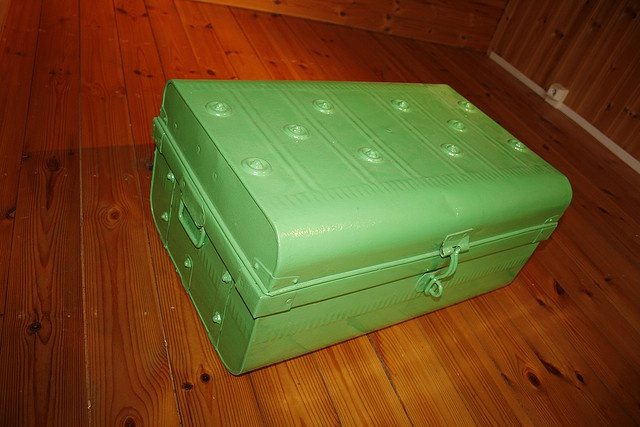Describe the objects in this image and their specific colors. I can see a suitcase in maroon, green, darkgreen, and lightgreen tones in this image. 